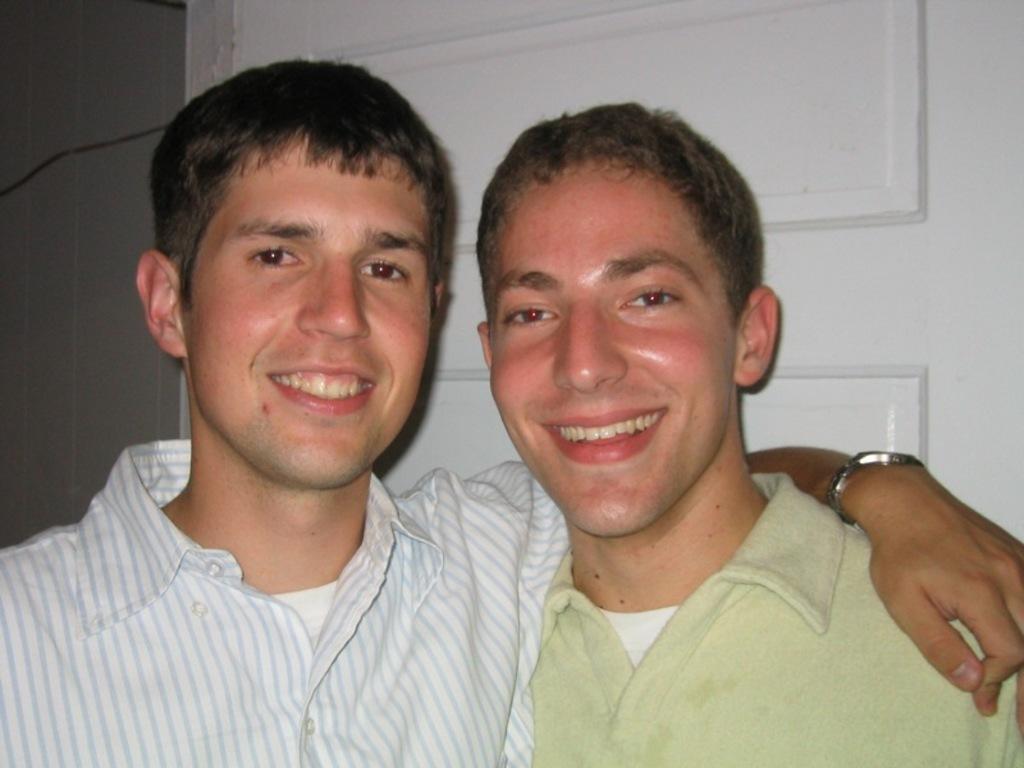In one or two sentences, can you explain what this image depicts? There are two men smiling. Person on the left is wearing watch. In the back there is a door. 